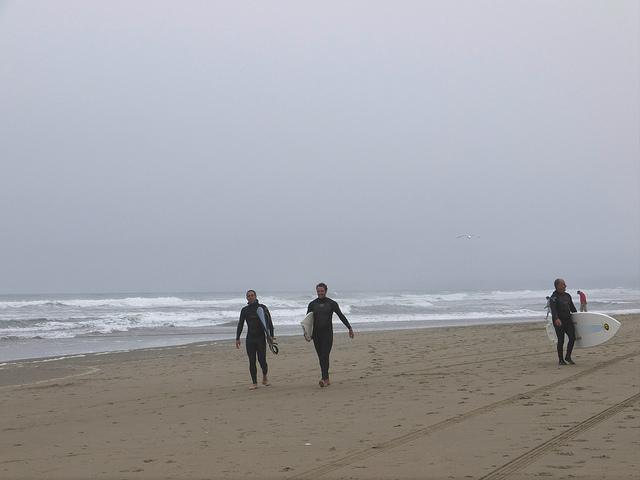The lines on the sand were made by what part of a vehicle?
Choose the correct response and explain in the format: 'Answer: answer
Rationale: rationale.'
Options: Trunk, tires, motor, bumper. Answer: tires.
Rationale: The lines came from the tires. 